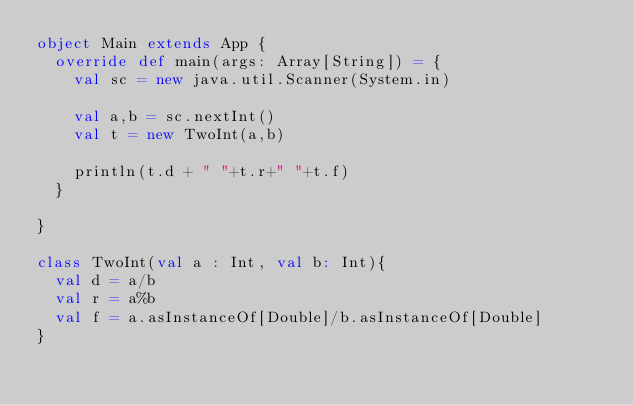Convert code to text. <code><loc_0><loc_0><loc_500><loc_500><_Scala_>object Main extends App {
	override def main(args: Array[String]) = {
		val sc = new java.util.Scanner(System.in)
		
		val a,b = sc.nextInt()	
		val t = new TwoInt(a,b)
		
		println(t.d + " "+t.r+" "+t.f)
	}
	
}

class TwoInt(val a : Int, val b: Int){
	val d = a/b
	val r = a%b
	val f = a.asInstanceOf[Double]/b.asInstanceOf[Double]
}</code> 